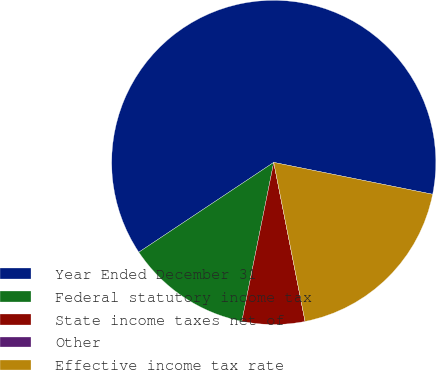Convert chart to OTSL. <chart><loc_0><loc_0><loc_500><loc_500><pie_chart><fcel>Year Ended December 31<fcel>Federal statutory income tax<fcel>State income taxes net of<fcel>Other<fcel>Effective income tax rate<nl><fcel>62.49%<fcel>12.5%<fcel>6.25%<fcel>0.0%<fcel>18.75%<nl></chart> 